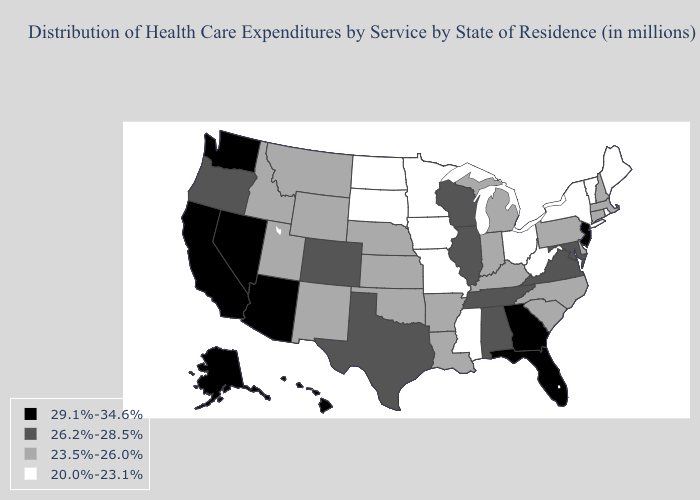What is the value of Mississippi?
Concise answer only. 20.0%-23.1%. Name the states that have a value in the range 20.0%-23.1%?
Answer briefly. Iowa, Maine, Minnesota, Mississippi, Missouri, New York, North Dakota, Ohio, Rhode Island, South Dakota, Vermont, West Virginia. Does California have the highest value in the West?
Quick response, please. Yes. What is the value of Idaho?
Quick response, please. 23.5%-26.0%. Which states hav the highest value in the South?
Quick response, please. Florida, Georgia. What is the value of North Dakota?
Be succinct. 20.0%-23.1%. Name the states that have a value in the range 26.2%-28.5%?
Write a very short answer. Alabama, Colorado, Illinois, Maryland, Oregon, Tennessee, Texas, Virginia, Wisconsin. What is the value of West Virginia?
Answer briefly. 20.0%-23.1%. Does Nebraska have a lower value than California?
Short answer required. Yes. Does North Carolina have a higher value than New York?
Give a very brief answer. Yes. Which states have the highest value in the USA?
Write a very short answer. Alaska, Arizona, California, Florida, Georgia, Hawaii, Nevada, New Jersey, Washington. Among the states that border Michigan , does Ohio have the lowest value?
Keep it brief. Yes. Which states have the lowest value in the West?
Be succinct. Idaho, Montana, New Mexico, Utah, Wyoming. What is the lowest value in the USA?
Write a very short answer. 20.0%-23.1%. Name the states that have a value in the range 26.2%-28.5%?
Short answer required. Alabama, Colorado, Illinois, Maryland, Oregon, Tennessee, Texas, Virginia, Wisconsin. 